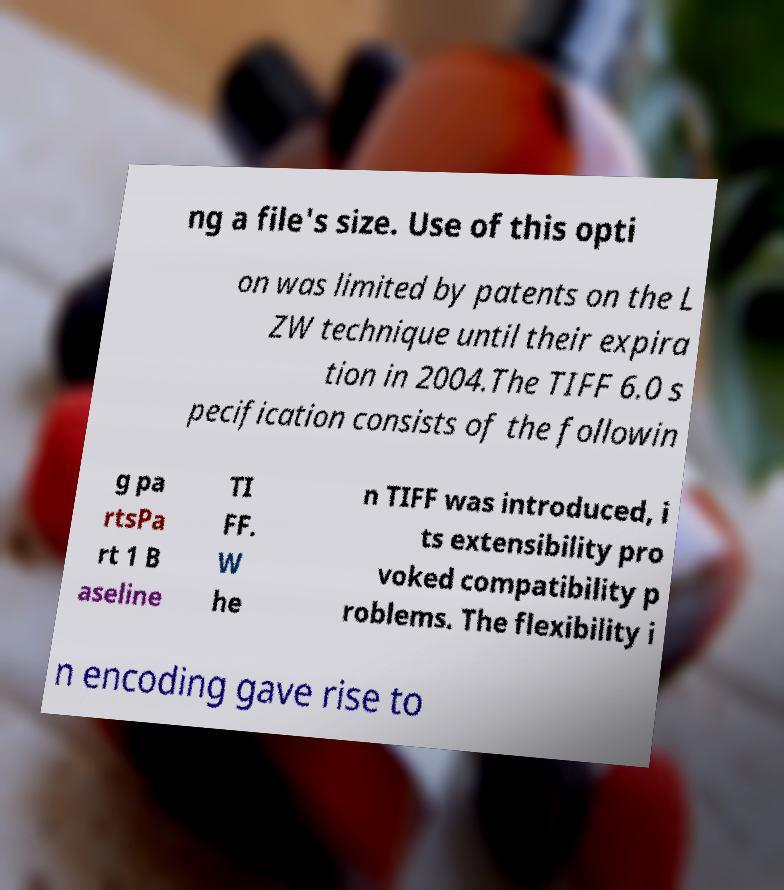Can you read and provide the text displayed in the image?This photo seems to have some interesting text. Can you extract and type it out for me? ng a file's size. Use of this opti on was limited by patents on the L ZW technique until their expira tion in 2004.The TIFF 6.0 s pecification consists of the followin g pa rtsPa rt 1 B aseline TI FF. W he n TIFF was introduced, i ts extensibility pro voked compatibility p roblems. The flexibility i n encoding gave rise to 